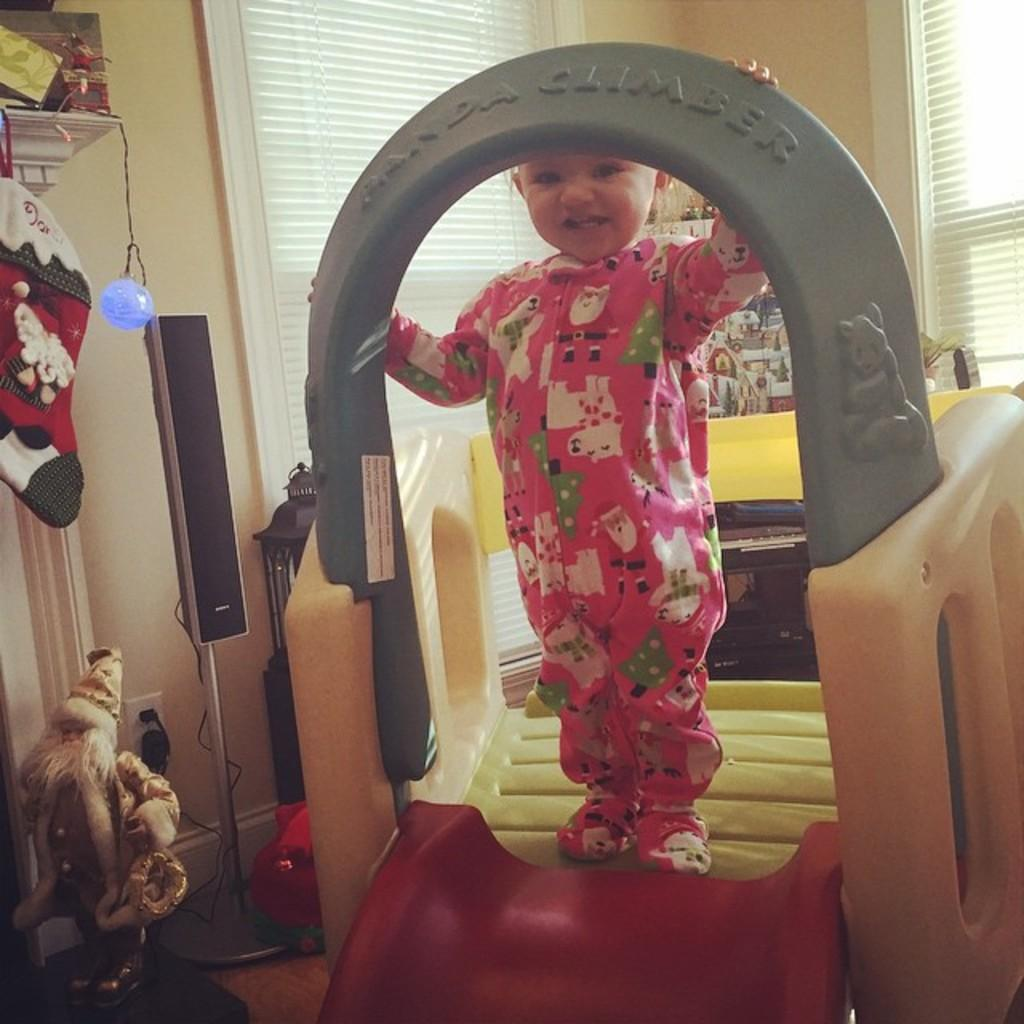What is the main subject of the image? The main subject of the image is a kid. What is the kid doing in the image? The kid is standing on a play slide. What is the kid's expression in the image? The kid is smiling. What can be seen in the background of the image? There is a wall and window blinds in the background of the image. What is present on the left side of the image? There are objects on the left side of the image. What type of sand can be seen in the image? There is no sand present in the image. What game is the kid playing with the kettle in the image? There is no game or kettle present in the image. 